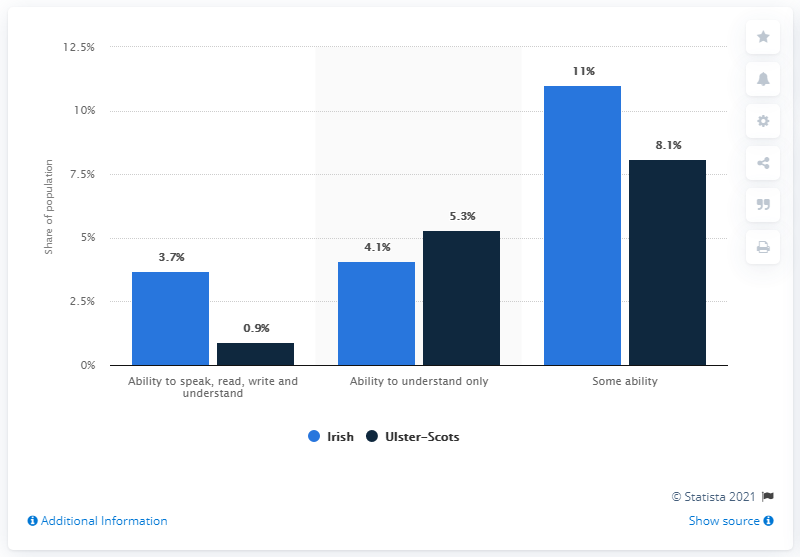Indicate a few pertinent items in this graphic. The highest blue bar is 11%. The value of the highest percentage bar in dark blue is 8.1%. 